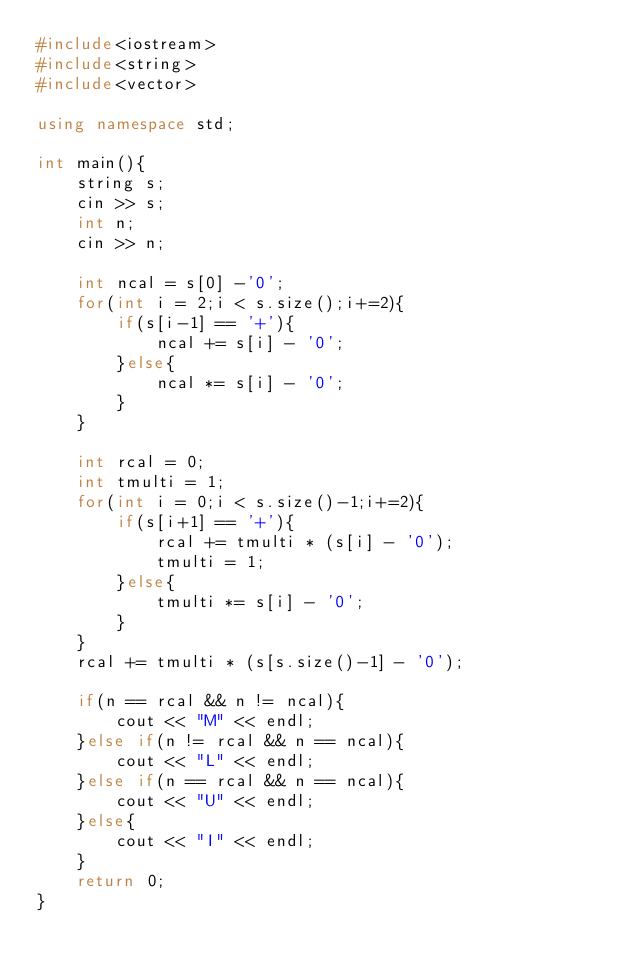Convert code to text. <code><loc_0><loc_0><loc_500><loc_500><_C++_>#include<iostream>
#include<string>
#include<vector>

using namespace std;

int main(){
	string s;
	cin >> s;
	int n;
	cin >> n;
	
	int ncal = s[0] -'0';
	for(int i = 2;i < s.size();i+=2){
		if(s[i-1] == '+'){
			ncal += s[i] - '0';
		}else{
			ncal *= s[i] - '0';
		}
	}
	
	int rcal = 0;
	int tmulti = 1;
	for(int i = 0;i < s.size()-1;i+=2){
		if(s[i+1] == '+'){
			rcal += tmulti * (s[i] - '0');
			tmulti = 1;
		}else{
			tmulti *= s[i] - '0';
		}
	}
	rcal += tmulti * (s[s.size()-1] - '0');
	
	if(n == rcal && n != ncal){
		cout << "M" << endl;
	}else if(n != rcal && n == ncal){
		cout << "L" << endl;
	}else if(n == rcal && n == ncal){
		cout << "U" << endl;
	}else{
		cout << "I" << endl;
	}
	return 0;
}
</code> 